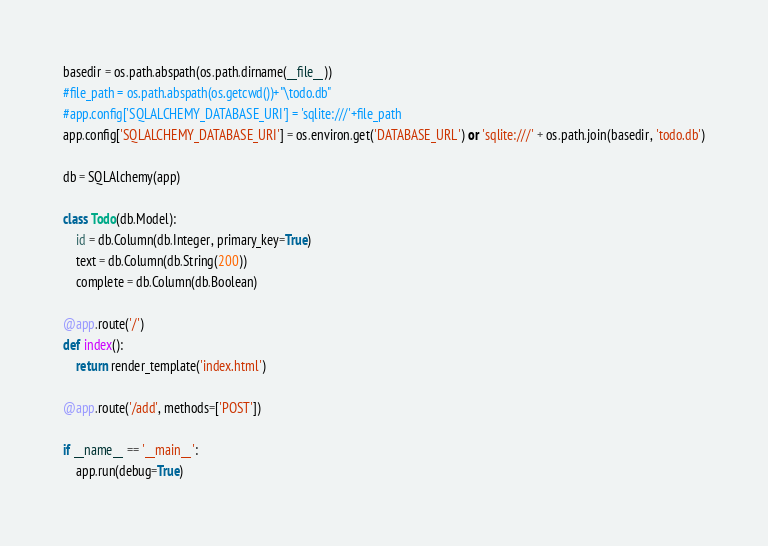Convert code to text. <code><loc_0><loc_0><loc_500><loc_500><_Python_>basedir = os.path.abspath(os.path.dirname(__file__))
#file_path = os.path.abspath(os.getcwd())+"\todo.db"
#app.config['SQLALCHEMY_DATABASE_URI'] = 'sqlite:///'+file_path
app.config['SQLALCHEMY_DATABASE_URI'] = os.environ.get('DATABASE_URL') or 'sqlite:///' + os.path.join(basedir, 'todo.db')

db = SQLAlchemy(app)

class Todo(db.Model):
	id = db.Column(db.Integer, primary_key=True)
	text = db.Column(db.String(200))
	complete = db.Column(db.Boolean)

@app.route('/')	
def index():
	return render_template('index.html')

@app.route('/add', methods=['POST'])

if __name__ == '__main__':
	app.run(debug=True)
</code> 